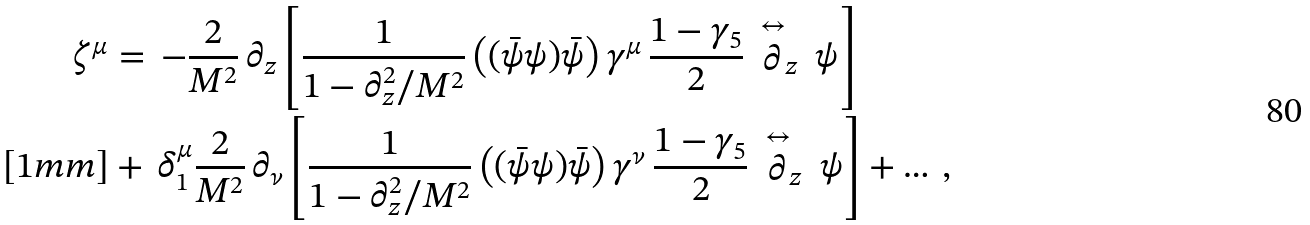<formula> <loc_0><loc_0><loc_500><loc_500>\zeta ^ { \mu } & = \, - \frac { 2 } { M ^ { 2 } } \, \partial _ { z } \left [ \frac { 1 } { 1 - \partial _ { z } ^ { 2 } / M ^ { 2 } } \left ( ( \bar { \psi } \psi ) \bar { \psi } \right ) \gamma ^ { \mu } \, \frac { 1 - \gamma _ { 5 } } { 2 } \, \stackrel { \leftrightarrow } \partial _ { z } \, \psi \right ] \\ [ 1 m m ] & + \, \delta ^ { \mu } _ { 1 } \frac { 2 } { M ^ { 2 } } \, \partial _ { \nu } \left [ \frac { 1 } { 1 - \partial _ { z } ^ { 2 } / M ^ { 2 } } \left ( ( \bar { \psi } \psi ) \bar { \psi } \right ) \gamma ^ { \nu } \, \frac { 1 - \gamma _ { 5 } } { 2 } \, \stackrel { \leftrightarrow } \partial _ { z } \, \psi \right ] + \dots \, ,</formula> 